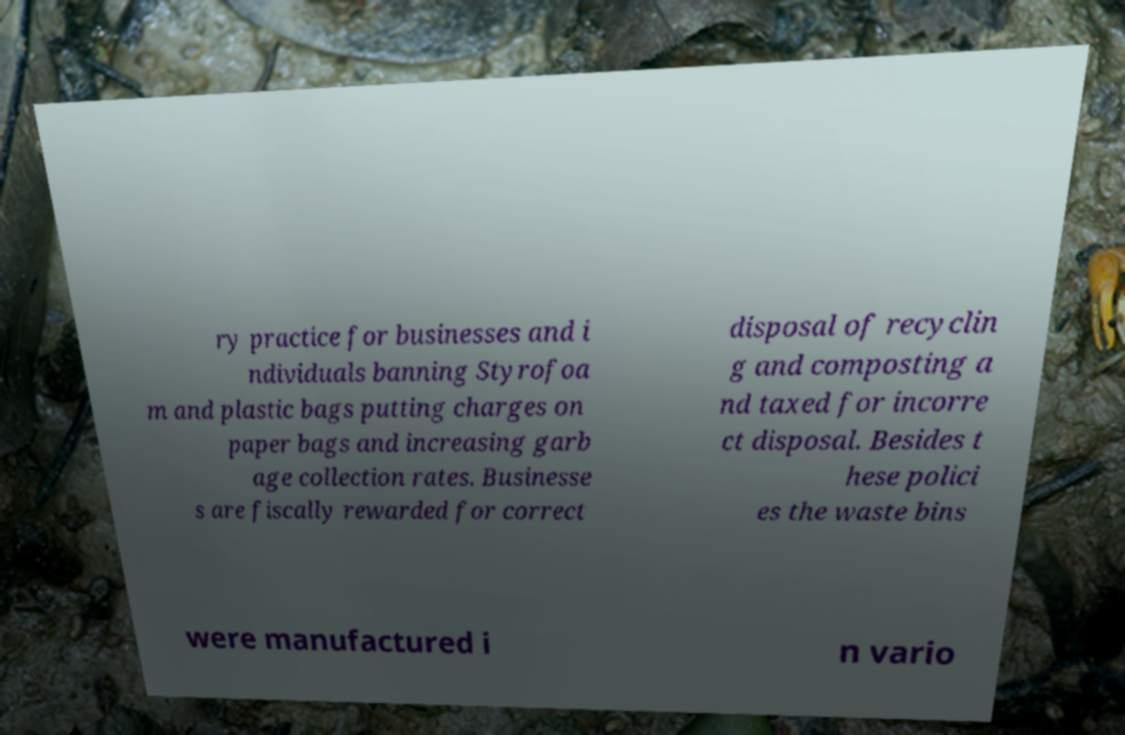Can you accurately transcribe the text from the provided image for me? ry practice for businesses and i ndividuals banning Styrofoa m and plastic bags putting charges on paper bags and increasing garb age collection rates. Businesse s are fiscally rewarded for correct disposal of recyclin g and composting a nd taxed for incorre ct disposal. Besides t hese polici es the waste bins were manufactured i n vario 